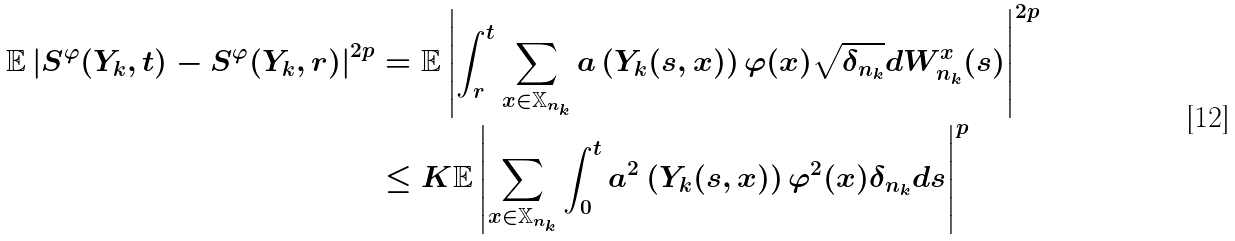Convert formula to latex. <formula><loc_0><loc_0><loc_500><loc_500>\mathbb { E } \left | S ^ { \varphi } ( Y _ { k } , t ) - S ^ { \varphi } ( Y _ { k } , r ) \right | ^ { 2 p } & = \mathbb { E } \left | \int _ { r } ^ { t } \sum _ { x \in { \mathbb { X } } _ { n _ { k } } } a \left ( Y _ { k } ( s , x ) \right ) \varphi ( x ) \sqrt { \delta _ { n _ { k } } } d W ^ { x } _ { n _ { k } } ( s ) \right | ^ { 2 p } \\ & \leq K \mathbb { E } \left | \sum _ { x \in { \mathbb { X } } _ { n _ { k } } } \int _ { 0 } ^ { t } a ^ { 2 } \left ( Y _ { k } ( s , x ) \right ) \varphi ^ { 2 } ( x ) \delta _ { n _ { k } } d s \right | ^ { p }</formula> 